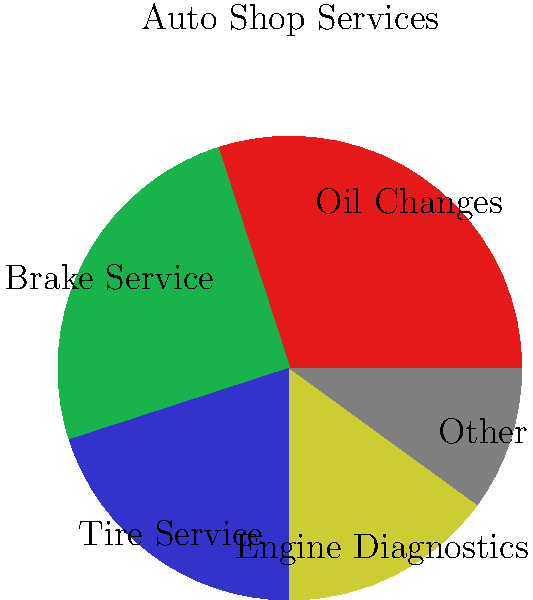Based on the pie chart showing the breakdown of services offered by a trustworthy auto shop, which two services combined account for more than half of the shop's total services? To determine which two services combined account for more than half of the shop's total services, we need to follow these steps:

1. Identify the two largest segments in the pie chart.
2. Add their percentages together.
3. Check if the sum exceeds 50% (half of the total services).

From the pie chart, we can see:

1. The two largest segments are:
   - Oil Changes: 30%
   - Brake Service: 25%

2. Adding these percentages:
   $30\% + 25\% = 55\%$

3. Checking if the sum exceeds 50%:
   $55\% > 50\%$

Therefore, Oil Changes and Brake Service combined account for 55% of the shop's total services, which is more than half.
Answer: Oil Changes and Brake Service 